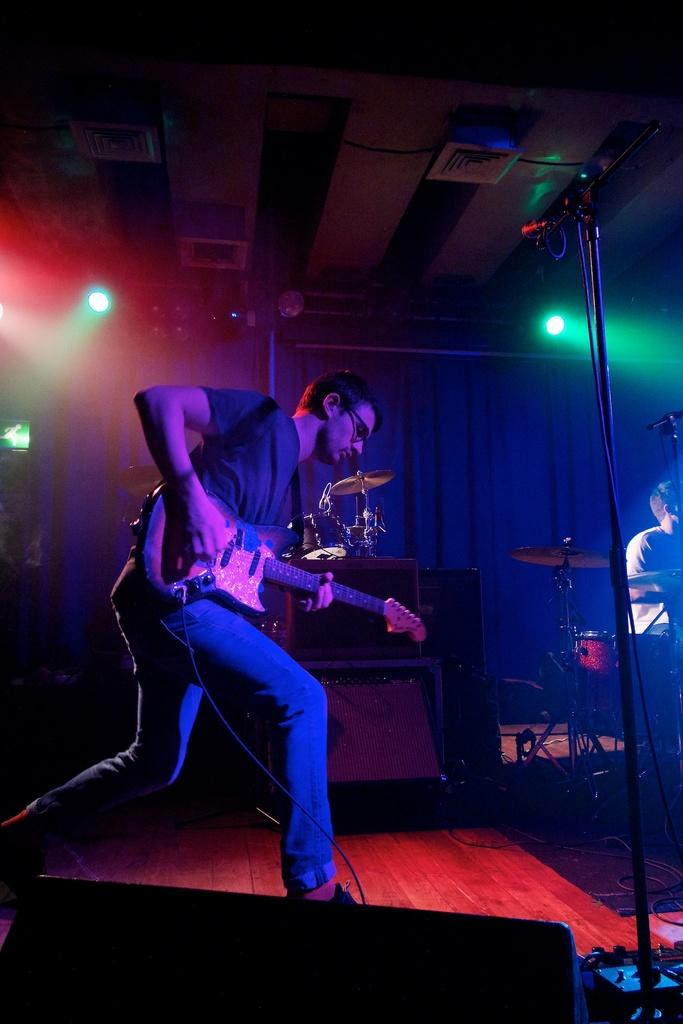What is the man in the image doing? The man is standing in the image. What object is the man holding in the image? The man is holding a guitar. What can be seen in the background of the image? There is a curtain in the background of the image. What type of belief is the man expressing in the image? There is no indication of any belief being expressed in the image; the man is simply standing and holding a guitar. 